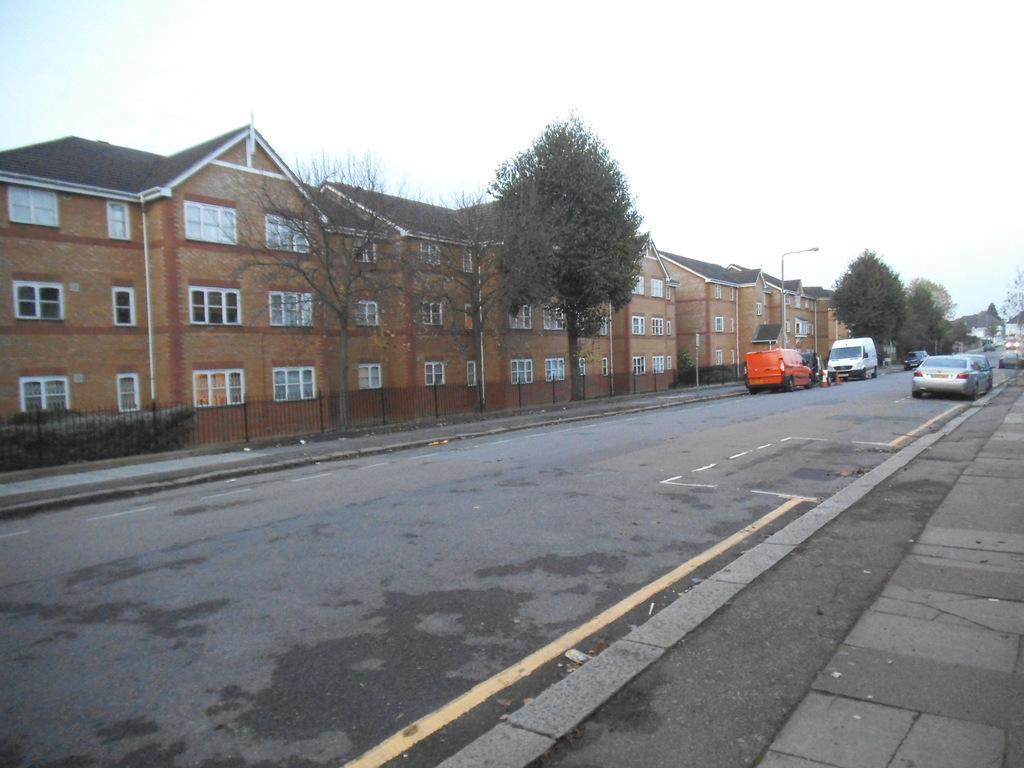How would you summarize this image in a sentence or two? The picture is clicked outside on a street. In the middle of the picture there are trees, buildings, footpath, street light and vehicles. In the foreground we can see road and footpath. Towards right there are cars. At the top we can see sky. 